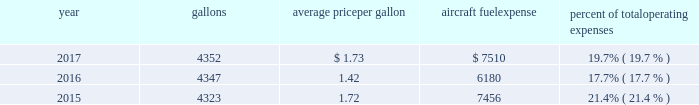( 2 ) our union-represented mainline employees are covered by agreements that are not currently amendable .
Joint collective bargaining agreements ( jcbas ) have been reached with post-merger employee groups , except the maintenance , fleet service , stock clerks , maintenance control technicians and maintenance training instructors represented by the twu-iam association who are covered by separate cbas that become amendable in the third quarter of 2018 .
Until those agreements become amendable , negotiations for jcbas will be conducted outside the traditional rla bargaining process as described above , and , in the meantime , no self-help will be permissible .
( 3 ) among our wholly-owned regional subsidiaries , the psa mechanics and flight attendants have agreements that are now amendable and are engaged in traditional rla negotiations .
The envoy passenger service employees are engaged in traditional rla negotiations for an initial cba .
The piedmont fleet and passenger service employees have reached a tentative five-year agreement which is subject to membership ratification .
For more discussion , see part i , item 1a .
Risk factors 2013 201cunion disputes , employee strikes and other labor-related disruptions may adversely affect our operations . 201d aircraft fuel our operations and financial results are significantly affected by the availability and price of jet fuel , which is our second largest expense .
Based on our 2018 forecasted mainline and regional fuel consumption , we estimate that a one cent per gallon increase in aviation fuel price would increase our 2018 annual fuel expense by $ 45 million .
The table shows annual aircraft fuel consumption and costs , including taxes , for our mainline and regional operations for 2017 , 2016 and 2015 ( gallons and aircraft fuel expense in millions ) .
Year gallons average price per gallon aircraft fuel expense percent of total operating expenses .
As of december 31 , 2017 , we did not have any fuel hedging contracts outstanding to hedge our fuel consumption .
As such , and assuming we do not enter into any future transactions to hedge our fuel consumption , we will continue to be fully exposed to fluctuations in fuel prices .
Our current policy is not to enter into transactions to hedge our fuel consumption , although we review that policy from time to time based on market conditions and other factors .
Fuel prices have fluctuated substantially over the past several years .
We cannot predict the future availability , price volatility or cost of aircraft fuel .
Natural disasters ( including hurricanes or similar events in the u.s .
Southeast and on the gulf coast where a significant portion of domestic refining capacity is located ) , political disruptions or wars involving oil-producing countries , changes in fuel-related governmental policy , the strength of the u.s .
Dollar against foreign currencies , changes in access to petroleum product pipelines and terminals , speculation in the energy futures markets , changes in aircraft fuel production capacity , environmental concerns and other unpredictable events may result in fuel supply shortages , distribution challenges , additional fuel price volatility and cost increases in the future .
See part i , item 1a .
Risk factors 2013 201cour business is very dependent on the price and availability of aircraft fuel .
Continued periods of high volatility in fuel costs , increased fuel prices or significant disruptions in the supply of aircraft fuel could have a significant negative impact on our operating results and liquidity . 201d seasonality and other factors due to the greater demand for air travel during the summer months , revenues in the airline industry in the second and third quarters of the year tend to be greater than revenues in the first and fourth quarters of the year .
General economic conditions , fears of terrorism or war , fare initiatives , fluctuations in fuel prices , labor actions , weather , natural disasters , outbreaks of disease and other factors could impact this seasonal pattern .
Therefore , our quarterly results of operations are not necessarily indicative of operating results for the entire year , and historical operating results in a quarterly or annual period are not necessarily indicative of future operating results. .
What are the total operating expenses based on the aircraft fuel expense in 2017? 
Computations: (7510 / 19.7%)
Answer: 38121.82741. 